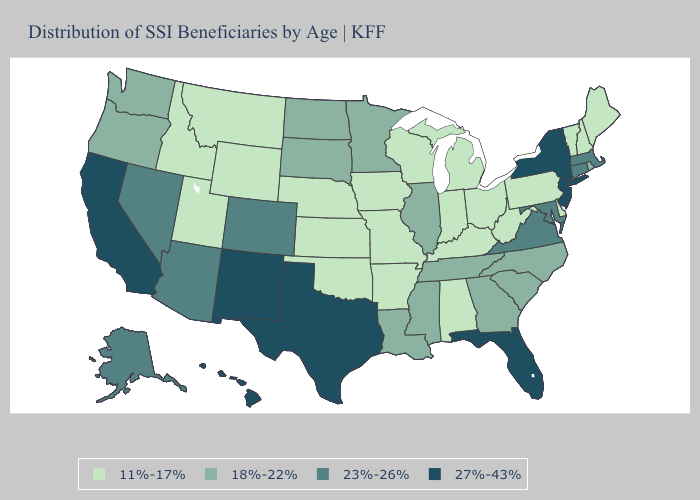Name the states that have a value in the range 23%-26%?
Short answer required. Alaska, Arizona, Colorado, Connecticut, Maryland, Massachusetts, Nevada, Virginia. Does Ohio have the same value as Mississippi?
Concise answer only. No. Name the states that have a value in the range 11%-17%?
Answer briefly. Alabama, Arkansas, Delaware, Idaho, Indiana, Iowa, Kansas, Kentucky, Maine, Michigan, Missouri, Montana, Nebraska, New Hampshire, Ohio, Oklahoma, Pennsylvania, Utah, Vermont, West Virginia, Wisconsin, Wyoming. What is the lowest value in the MidWest?
Concise answer only. 11%-17%. Which states have the highest value in the USA?
Write a very short answer. California, Florida, Hawaii, New Jersey, New Mexico, New York, Texas. Name the states that have a value in the range 11%-17%?
Quick response, please. Alabama, Arkansas, Delaware, Idaho, Indiana, Iowa, Kansas, Kentucky, Maine, Michigan, Missouri, Montana, Nebraska, New Hampshire, Ohio, Oklahoma, Pennsylvania, Utah, Vermont, West Virginia, Wisconsin, Wyoming. Does the map have missing data?
Answer briefly. No. Does New Hampshire have the lowest value in the Northeast?
Concise answer only. Yes. Is the legend a continuous bar?
Short answer required. No. Does Florida have the highest value in the USA?
Keep it brief. Yes. Name the states that have a value in the range 23%-26%?
Give a very brief answer. Alaska, Arizona, Colorado, Connecticut, Maryland, Massachusetts, Nevada, Virginia. Does the map have missing data?
Give a very brief answer. No. Name the states that have a value in the range 18%-22%?
Answer briefly. Georgia, Illinois, Louisiana, Minnesota, Mississippi, North Carolina, North Dakota, Oregon, Rhode Island, South Carolina, South Dakota, Tennessee, Washington. What is the value of Alaska?
Short answer required. 23%-26%. What is the value of Idaho?
Be succinct. 11%-17%. 